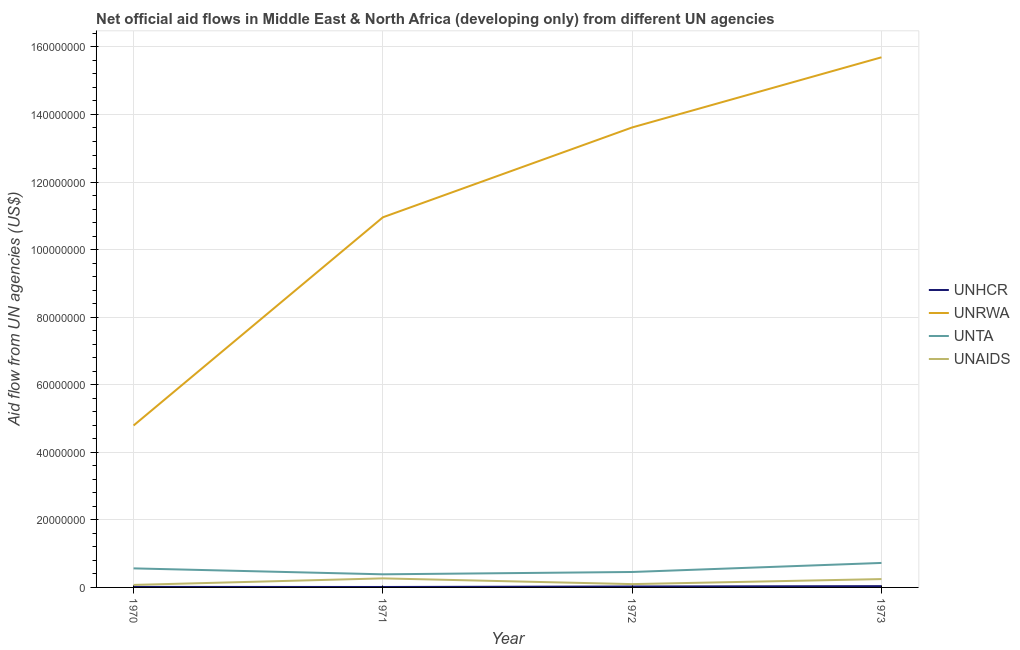How many different coloured lines are there?
Your answer should be very brief. 4. Is the number of lines equal to the number of legend labels?
Your response must be concise. Yes. What is the amount of aid given by unhcr in 1973?
Ensure brevity in your answer.  3.80e+05. Across all years, what is the maximum amount of aid given by unrwa?
Give a very brief answer. 1.57e+08. Across all years, what is the minimum amount of aid given by unta?
Give a very brief answer. 3.88e+06. What is the total amount of aid given by unaids in the graph?
Give a very brief answer. 6.87e+06. What is the difference between the amount of aid given by unhcr in 1972 and that in 1973?
Your response must be concise. -1.00e+05. What is the difference between the amount of aid given by unaids in 1971 and the amount of aid given by unta in 1970?
Make the answer very short. -2.96e+06. What is the average amount of aid given by unta per year?
Your answer should be very brief. 5.34e+06. In the year 1973, what is the difference between the amount of aid given by unhcr and amount of aid given by unaids?
Ensure brevity in your answer.  -2.09e+06. What is the ratio of the amount of aid given by unaids in 1970 to that in 1971?
Your response must be concise. 0.28. Is the amount of aid given by unta in 1971 less than that in 1972?
Keep it short and to the point. Yes. What is the difference between the highest and the second highest amount of aid given by unta?
Make the answer very short. 1.61e+06. What is the difference between the highest and the lowest amount of aid given by unaids?
Give a very brief answer. 1.94e+06. Is it the case that in every year, the sum of the amount of aid given by unhcr and amount of aid given by unta is greater than the sum of amount of aid given by unrwa and amount of aid given by unaids?
Offer a very short reply. Yes. Is it the case that in every year, the sum of the amount of aid given by unhcr and amount of aid given by unrwa is greater than the amount of aid given by unta?
Provide a short and direct response. Yes. Is the amount of aid given by unaids strictly greater than the amount of aid given by unhcr over the years?
Offer a very short reply. Yes. How many years are there in the graph?
Ensure brevity in your answer.  4. What is the difference between two consecutive major ticks on the Y-axis?
Your response must be concise. 2.00e+07. Does the graph contain any zero values?
Ensure brevity in your answer.  No. What is the title of the graph?
Make the answer very short. Net official aid flows in Middle East & North Africa (developing only) from different UN agencies. Does "Regional development banks" appear as one of the legend labels in the graph?
Keep it short and to the point. No. What is the label or title of the Y-axis?
Your answer should be compact. Aid flow from UN agencies (US$). What is the Aid flow from UN agencies (US$) in UNHCR in 1970?
Provide a succinct answer. 1.60e+05. What is the Aid flow from UN agencies (US$) in UNRWA in 1970?
Your answer should be very brief. 4.79e+07. What is the Aid flow from UN agencies (US$) in UNTA in 1970?
Your answer should be very brief. 5.64e+06. What is the Aid flow from UN agencies (US$) of UNAIDS in 1970?
Make the answer very short. 7.40e+05. What is the Aid flow from UN agencies (US$) in UNHCR in 1971?
Your answer should be compact. 1.30e+05. What is the Aid flow from UN agencies (US$) in UNRWA in 1971?
Your answer should be compact. 1.10e+08. What is the Aid flow from UN agencies (US$) of UNTA in 1971?
Offer a terse response. 3.88e+06. What is the Aid flow from UN agencies (US$) in UNAIDS in 1971?
Make the answer very short. 2.68e+06. What is the Aid flow from UN agencies (US$) of UNRWA in 1972?
Make the answer very short. 1.36e+08. What is the Aid flow from UN agencies (US$) of UNTA in 1972?
Offer a terse response. 4.57e+06. What is the Aid flow from UN agencies (US$) of UNAIDS in 1972?
Offer a very short reply. 9.80e+05. What is the Aid flow from UN agencies (US$) in UNHCR in 1973?
Ensure brevity in your answer.  3.80e+05. What is the Aid flow from UN agencies (US$) in UNRWA in 1973?
Provide a short and direct response. 1.57e+08. What is the Aid flow from UN agencies (US$) in UNTA in 1973?
Make the answer very short. 7.25e+06. What is the Aid flow from UN agencies (US$) in UNAIDS in 1973?
Make the answer very short. 2.47e+06. Across all years, what is the maximum Aid flow from UN agencies (US$) of UNHCR?
Ensure brevity in your answer.  3.80e+05. Across all years, what is the maximum Aid flow from UN agencies (US$) of UNRWA?
Provide a succinct answer. 1.57e+08. Across all years, what is the maximum Aid flow from UN agencies (US$) of UNTA?
Give a very brief answer. 7.25e+06. Across all years, what is the maximum Aid flow from UN agencies (US$) in UNAIDS?
Offer a very short reply. 2.68e+06. Across all years, what is the minimum Aid flow from UN agencies (US$) of UNHCR?
Make the answer very short. 1.30e+05. Across all years, what is the minimum Aid flow from UN agencies (US$) of UNRWA?
Offer a very short reply. 4.79e+07. Across all years, what is the minimum Aid flow from UN agencies (US$) of UNTA?
Provide a succinct answer. 3.88e+06. Across all years, what is the minimum Aid flow from UN agencies (US$) of UNAIDS?
Your answer should be very brief. 7.40e+05. What is the total Aid flow from UN agencies (US$) in UNHCR in the graph?
Ensure brevity in your answer.  9.50e+05. What is the total Aid flow from UN agencies (US$) of UNRWA in the graph?
Your answer should be compact. 4.51e+08. What is the total Aid flow from UN agencies (US$) in UNTA in the graph?
Your answer should be very brief. 2.13e+07. What is the total Aid flow from UN agencies (US$) of UNAIDS in the graph?
Offer a very short reply. 6.87e+06. What is the difference between the Aid flow from UN agencies (US$) of UNHCR in 1970 and that in 1971?
Offer a very short reply. 3.00e+04. What is the difference between the Aid flow from UN agencies (US$) of UNRWA in 1970 and that in 1971?
Provide a succinct answer. -6.16e+07. What is the difference between the Aid flow from UN agencies (US$) of UNTA in 1970 and that in 1971?
Ensure brevity in your answer.  1.76e+06. What is the difference between the Aid flow from UN agencies (US$) of UNAIDS in 1970 and that in 1971?
Ensure brevity in your answer.  -1.94e+06. What is the difference between the Aid flow from UN agencies (US$) of UNHCR in 1970 and that in 1972?
Keep it short and to the point. -1.20e+05. What is the difference between the Aid flow from UN agencies (US$) in UNRWA in 1970 and that in 1972?
Provide a succinct answer. -8.82e+07. What is the difference between the Aid flow from UN agencies (US$) of UNTA in 1970 and that in 1972?
Make the answer very short. 1.07e+06. What is the difference between the Aid flow from UN agencies (US$) in UNAIDS in 1970 and that in 1972?
Your answer should be compact. -2.40e+05. What is the difference between the Aid flow from UN agencies (US$) in UNHCR in 1970 and that in 1973?
Your answer should be very brief. -2.20e+05. What is the difference between the Aid flow from UN agencies (US$) of UNRWA in 1970 and that in 1973?
Ensure brevity in your answer.  -1.09e+08. What is the difference between the Aid flow from UN agencies (US$) of UNTA in 1970 and that in 1973?
Make the answer very short. -1.61e+06. What is the difference between the Aid flow from UN agencies (US$) of UNAIDS in 1970 and that in 1973?
Ensure brevity in your answer.  -1.73e+06. What is the difference between the Aid flow from UN agencies (US$) of UNRWA in 1971 and that in 1972?
Offer a terse response. -2.66e+07. What is the difference between the Aid flow from UN agencies (US$) of UNTA in 1971 and that in 1972?
Make the answer very short. -6.90e+05. What is the difference between the Aid flow from UN agencies (US$) in UNAIDS in 1971 and that in 1972?
Give a very brief answer. 1.70e+06. What is the difference between the Aid flow from UN agencies (US$) of UNRWA in 1971 and that in 1973?
Provide a succinct answer. -4.74e+07. What is the difference between the Aid flow from UN agencies (US$) of UNTA in 1971 and that in 1973?
Give a very brief answer. -3.37e+06. What is the difference between the Aid flow from UN agencies (US$) in UNHCR in 1972 and that in 1973?
Provide a succinct answer. -1.00e+05. What is the difference between the Aid flow from UN agencies (US$) in UNRWA in 1972 and that in 1973?
Your answer should be compact. -2.08e+07. What is the difference between the Aid flow from UN agencies (US$) in UNTA in 1972 and that in 1973?
Provide a short and direct response. -2.68e+06. What is the difference between the Aid flow from UN agencies (US$) in UNAIDS in 1972 and that in 1973?
Ensure brevity in your answer.  -1.49e+06. What is the difference between the Aid flow from UN agencies (US$) of UNHCR in 1970 and the Aid flow from UN agencies (US$) of UNRWA in 1971?
Make the answer very short. -1.09e+08. What is the difference between the Aid flow from UN agencies (US$) of UNHCR in 1970 and the Aid flow from UN agencies (US$) of UNTA in 1971?
Provide a short and direct response. -3.72e+06. What is the difference between the Aid flow from UN agencies (US$) of UNHCR in 1970 and the Aid flow from UN agencies (US$) of UNAIDS in 1971?
Your response must be concise. -2.52e+06. What is the difference between the Aid flow from UN agencies (US$) in UNRWA in 1970 and the Aid flow from UN agencies (US$) in UNTA in 1971?
Offer a terse response. 4.40e+07. What is the difference between the Aid flow from UN agencies (US$) in UNRWA in 1970 and the Aid flow from UN agencies (US$) in UNAIDS in 1971?
Give a very brief answer. 4.52e+07. What is the difference between the Aid flow from UN agencies (US$) of UNTA in 1970 and the Aid flow from UN agencies (US$) of UNAIDS in 1971?
Make the answer very short. 2.96e+06. What is the difference between the Aid flow from UN agencies (US$) of UNHCR in 1970 and the Aid flow from UN agencies (US$) of UNRWA in 1972?
Ensure brevity in your answer.  -1.36e+08. What is the difference between the Aid flow from UN agencies (US$) in UNHCR in 1970 and the Aid flow from UN agencies (US$) in UNTA in 1972?
Ensure brevity in your answer.  -4.41e+06. What is the difference between the Aid flow from UN agencies (US$) of UNHCR in 1970 and the Aid flow from UN agencies (US$) of UNAIDS in 1972?
Make the answer very short. -8.20e+05. What is the difference between the Aid flow from UN agencies (US$) of UNRWA in 1970 and the Aid flow from UN agencies (US$) of UNTA in 1972?
Offer a very short reply. 4.34e+07. What is the difference between the Aid flow from UN agencies (US$) of UNRWA in 1970 and the Aid flow from UN agencies (US$) of UNAIDS in 1972?
Your answer should be compact. 4.70e+07. What is the difference between the Aid flow from UN agencies (US$) in UNTA in 1970 and the Aid flow from UN agencies (US$) in UNAIDS in 1972?
Ensure brevity in your answer.  4.66e+06. What is the difference between the Aid flow from UN agencies (US$) of UNHCR in 1970 and the Aid flow from UN agencies (US$) of UNRWA in 1973?
Your response must be concise. -1.57e+08. What is the difference between the Aid flow from UN agencies (US$) in UNHCR in 1970 and the Aid flow from UN agencies (US$) in UNTA in 1973?
Keep it short and to the point. -7.09e+06. What is the difference between the Aid flow from UN agencies (US$) of UNHCR in 1970 and the Aid flow from UN agencies (US$) of UNAIDS in 1973?
Keep it short and to the point. -2.31e+06. What is the difference between the Aid flow from UN agencies (US$) in UNRWA in 1970 and the Aid flow from UN agencies (US$) in UNTA in 1973?
Keep it short and to the point. 4.07e+07. What is the difference between the Aid flow from UN agencies (US$) of UNRWA in 1970 and the Aid flow from UN agencies (US$) of UNAIDS in 1973?
Your response must be concise. 4.55e+07. What is the difference between the Aid flow from UN agencies (US$) in UNTA in 1970 and the Aid flow from UN agencies (US$) in UNAIDS in 1973?
Ensure brevity in your answer.  3.17e+06. What is the difference between the Aid flow from UN agencies (US$) of UNHCR in 1971 and the Aid flow from UN agencies (US$) of UNRWA in 1972?
Provide a short and direct response. -1.36e+08. What is the difference between the Aid flow from UN agencies (US$) in UNHCR in 1971 and the Aid flow from UN agencies (US$) in UNTA in 1972?
Offer a very short reply. -4.44e+06. What is the difference between the Aid flow from UN agencies (US$) in UNHCR in 1971 and the Aid flow from UN agencies (US$) in UNAIDS in 1972?
Make the answer very short. -8.50e+05. What is the difference between the Aid flow from UN agencies (US$) of UNRWA in 1971 and the Aid flow from UN agencies (US$) of UNTA in 1972?
Ensure brevity in your answer.  1.05e+08. What is the difference between the Aid flow from UN agencies (US$) in UNRWA in 1971 and the Aid flow from UN agencies (US$) in UNAIDS in 1972?
Keep it short and to the point. 1.09e+08. What is the difference between the Aid flow from UN agencies (US$) of UNTA in 1971 and the Aid flow from UN agencies (US$) of UNAIDS in 1972?
Ensure brevity in your answer.  2.90e+06. What is the difference between the Aid flow from UN agencies (US$) of UNHCR in 1971 and the Aid flow from UN agencies (US$) of UNRWA in 1973?
Offer a terse response. -1.57e+08. What is the difference between the Aid flow from UN agencies (US$) in UNHCR in 1971 and the Aid flow from UN agencies (US$) in UNTA in 1973?
Your answer should be very brief. -7.12e+06. What is the difference between the Aid flow from UN agencies (US$) in UNHCR in 1971 and the Aid flow from UN agencies (US$) in UNAIDS in 1973?
Offer a terse response. -2.34e+06. What is the difference between the Aid flow from UN agencies (US$) in UNRWA in 1971 and the Aid flow from UN agencies (US$) in UNTA in 1973?
Offer a terse response. 1.02e+08. What is the difference between the Aid flow from UN agencies (US$) in UNRWA in 1971 and the Aid flow from UN agencies (US$) in UNAIDS in 1973?
Offer a terse response. 1.07e+08. What is the difference between the Aid flow from UN agencies (US$) of UNTA in 1971 and the Aid flow from UN agencies (US$) of UNAIDS in 1973?
Your answer should be compact. 1.41e+06. What is the difference between the Aid flow from UN agencies (US$) of UNHCR in 1972 and the Aid flow from UN agencies (US$) of UNRWA in 1973?
Provide a succinct answer. -1.57e+08. What is the difference between the Aid flow from UN agencies (US$) in UNHCR in 1972 and the Aid flow from UN agencies (US$) in UNTA in 1973?
Offer a terse response. -6.97e+06. What is the difference between the Aid flow from UN agencies (US$) of UNHCR in 1972 and the Aid flow from UN agencies (US$) of UNAIDS in 1973?
Provide a succinct answer. -2.19e+06. What is the difference between the Aid flow from UN agencies (US$) of UNRWA in 1972 and the Aid flow from UN agencies (US$) of UNTA in 1973?
Provide a short and direct response. 1.29e+08. What is the difference between the Aid flow from UN agencies (US$) in UNRWA in 1972 and the Aid flow from UN agencies (US$) in UNAIDS in 1973?
Provide a succinct answer. 1.34e+08. What is the difference between the Aid flow from UN agencies (US$) in UNTA in 1972 and the Aid flow from UN agencies (US$) in UNAIDS in 1973?
Keep it short and to the point. 2.10e+06. What is the average Aid flow from UN agencies (US$) in UNHCR per year?
Offer a very short reply. 2.38e+05. What is the average Aid flow from UN agencies (US$) of UNRWA per year?
Make the answer very short. 1.13e+08. What is the average Aid flow from UN agencies (US$) of UNTA per year?
Provide a short and direct response. 5.34e+06. What is the average Aid flow from UN agencies (US$) of UNAIDS per year?
Your answer should be compact. 1.72e+06. In the year 1970, what is the difference between the Aid flow from UN agencies (US$) of UNHCR and Aid flow from UN agencies (US$) of UNRWA?
Provide a short and direct response. -4.78e+07. In the year 1970, what is the difference between the Aid flow from UN agencies (US$) of UNHCR and Aid flow from UN agencies (US$) of UNTA?
Ensure brevity in your answer.  -5.48e+06. In the year 1970, what is the difference between the Aid flow from UN agencies (US$) of UNHCR and Aid flow from UN agencies (US$) of UNAIDS?
Keep it short and to the point. -5.80e+05. In the year 1970, what is the difference between the Aid flow from UN agencies (US$) in UNRWA and Aid flow from UN agencies (US$) in UNTA?
Provide a short and direct response. 4.23e+07. In the year 1970, what is the difference between the Aid flow from UN agencies (US$) of UNRWA and Aid flow from UN agencies (US$) of UNAIDS?
Ensure brevity in your answer.  4.72e+07. In the year 1970, what is the difference between the Aid flow from UN agencies (US$) of UNTA and Aid flow from UN agencies (US$) of UNAIDS?
Give a very brief answer. 4.90e+06. In the year 1971, what is the difference between the Aid flow from UN agencies (US$) of UNHCR and Aid flow from UN agencies (US$) of UNRWA?
Ensure brevity in your answer.  -1.09e+08. In the year 1971, what is the difference between the Aid flow from UN agencies (US$) of UNHCR and Aid flow from UN agencies (US$) of UNTA?
Your response must be concise. -3.75e+06. In the year 1971, what is the difference between the Aid flow from UN agencies (US$) of UNHCR and Aid flow from UN agencies (US$) of UNAIDS?
Make the answer very short. -2.55e+06. In the year 1971, what is the difference between the Aid flow from UN agencies (US$) in UNRWA and Aid flow from UN agencies (US$) in UNTA?
Your answer should be very brief. 1.06e+08. In the year 1971, what is the difference between the Aid flow from UN agencies (US$) of UNRWA and Aid flow from UN agencies (US$) of UNAIDS?
Offer a very short reply. 1.07e+08. In the year 1971, what is the difference between the Aid flow from UN agencies (US$) in UNTA and Aid flow from UN agencies (US$) in UNAIDS?
Your answer should be compact. 1.20e+06. In the year 1972, what is the difference between the Aid flow from UN agencies (US$) in UNHCR and Aid flow from UN agencies (US$) in UNRWA?
Your answer should be compact. -1.36e+08. In the year 1972, what is the difference between the Aid flow from UN agencies (US$) of UNHCR and Aid flow from UN agencies (US$) of UNTA?
Offer a terse response. -4.29e+06. In the year 1972, what is the difference between the Aid flow from UN agencies (US$) in UNHCR and Aid flow from UN agencies (US$) in UNAIDS?
Offer a terse response. -7.00e+05. In the year 1972, what is the difference between the Aid flow from UN agencies (US$) in UNRWA and Aid flow from UN agencies (US$) in UNTA?
Give a very brief answer. 1.32e+08. In the year 1972, what is the difference between the Aid flow from UN agencies (US$) of UNRWA and Aid flow from UN agencies (US$) of UNAIDS?
Offer a very short reply. 1.35e+08. In the year 1972, what is the difference between the Aid flow from UN agencies (US$) in UNTA and Aid flow from UN agencies (US$) in UNAIDS?
Your answer should be very brief. 3.59e+06. In the year 1973, what is the difference between the Aid flow from UN agencies (US$) of UNHCR and Aid flow from UN agencies (US$) of UNRWA?
Give a very brief answer. -1.57e+08. In the year 1973, what is the difference between the Aid flow from UN agencies (US$) in UNHCR and Aid flow from UN agencies (US$) in UNTA?
Keep it short and to the point. -6.87e+06. In the year 1973, what is the difference between the Aid flow from UN agencies (US$) in UNHCR and Aid flow from UN agencies (US$) in UNAIDS?
Offer a very short reply. -2.09e+06. In the year 1973, what is the difference between the Aid flow from UN agencies (US$) of UNRWA and Aid flow from UN agencies (US$) of UNTA?
Provide a succinct answer. 1.50e+08. In the year 1973, what is the difference between the Aid flow from UN agencies (US$) in UNRWA and Aid flow from UN agencies (US$) in UNAIDS?
Offer a terse response. 1.54e+08. In the year 1973, what is the difference between the Aid flow from UN agencies (US$) of UNTA and Aid flow from UN agencies (US$) of UNAIDS?
Your response must be concise. 4.78e+06. What is the ratio of the Aid flow from UN agencies (US$) of UNHCR in 1970 to that in 1971?
Provide a short and direct response. 1.23. What is the ratio of the Aid flow from UN agencies (US$) in UNRWA in 1970 to that in 1971?
Make the answer very short. 0.44. What is the ratio of the Aid flow from UN agencies (US$) of UNTA in 1970 to that in 1971?
Your response must be concise. 1.45. What is the ratio of the Aid flow from UN agencies (US$) in UNAIDS in 1970 to that in 1971?
Provide a succinct answer. 0.28. What is the ratio of the Aid flow from UN agencies (US$) of UNRWA in 1970 to that in 1972?
Your answer should be compact. 0.35. What is the ratio of the Aid flow from UN agencies (US$) of UNTA in 1970 to that in 1972?
Offer a terse response. 1.23. What is the ratio of the Aid flow from UN agencies (US$) in UNAIDS in 1970 to that in 1972?
Provide a short and direct response. 0.76. What is the ratio of the Aid flow from UN agencies (US$) of UNHCR in 1970 to that in 1973?
Your answer should be very brief. 0.42. What is the ratio of the Aid flow from UN agencies (US$) in UNRWA in 1970 to that in 1973?
Keep it short and to the point. 0.31. What is the ratio of the Aid flow from UN agencies (US$) of UNTA in 1970 to that in 1973?
Offer a terse response. 0.78. What is the ratio of the Aid flow from UN agencies (US$) of UNAIDS in 1970 to that in 1973?
Make the answer very short. 0.3. What is the ratio of the Aid flow from UN agencies (US$) of UNHCR in 1971 to that in 1972?
Ensure brevity in your answer.  0.46. What is the ratio of the Aid flow from UN agencies (US$) of UNRWA in 1971 to that in 1972?
Your answer should be compact. 0.8. What is the ratio of the Aid flow from UN agencies (US$) of UNTA in 1971 to that in 1972?
Keep it short and to the point. 0.85. What is the ratio of the Aid flow from UN agencies (US$) of UNAIDS in 1971 to that in 1972?
Provide a short and direct response. 2.73. What is the ratio of the Aid flow from UN agencies (US$) in UNHCR in 1971 to that in 1973?
Keep it short and to the point. 0.34. What is the ratio of the Aid flow from UN agencies (US$) in UNRWA in 1971 to that in 1973?
Make the answer very short. 0.7. What is the ratio of the Aid flow from UN agencies (US$) of UNTA in 1971 to that in 1973?
Offer a terse response. 0.54. What is the ratio of the Aid flow from UN agencies (US$) in UNAIDS in 1971 to that in 1973?
Provide a short and direct response. 1.08. What is the ratio of the Aid flow from UN agencies (US$) in UNHCR in 1972 to that in 1973?
Make the answer very short. 0.74. What is the ratio of the Aid flow from UN agencies (US$) in UNRWA in 1972 to that in 1973?
Keep it short and to the point. 0.87. What is the ratio of the Aid flow from UN agencies (US$) of UNTA in 1972 to that in 1973?
Offer a terse response. 0.63. What is the ratio of the Aid flow from UN agencies (US$) of UNAIDS in 1972 to that in 1973?
Your answer should be compact. 0.4. What is the difference between the highest and the second highest Aid flow from UN agencies (US$) in UNHCR?
Provide a succinct answer. 1.00e+05. What is the difference between the highest and the second highest Aid flow from UN agencies (US$) in UNRWA?
Give a very brief answer. 2.08e+07. What is the difference between the highest and the second highest Aid flow from UN agencies (US$) in UNTA?
Your response must be concise. 1.61e+06. What is the difference between the highest and the second highest Aid flow from UN agencies (US$) in UNAIDS?
Keep it short and to the point. 2.10e+05. What is the difference between the highest and the lowest Aid flow from UN agencies (US$) in UNHCR?
Offer a terse response. 2.50e+05. What is the difference between the highest and the lowest Aid flow from UN agencies (US$) of UNRWA?
Your answer should be compact. 1.09e+08. What is the difference between the highest and the lowest Aid flow from UN agencies (US$) in UNTA?
Give a very brief answer. 3.37e+06. What is the difference between the highest and the lowest Aid flow from UN agencies (US$) in UNAIDS?
Offer a terse response. 1.94e+06. 